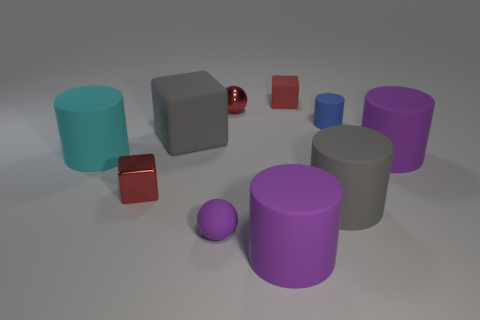Subtract all small cubes. How many cubes are left? 1 Subtract all cyan cylinders. How many cylinders are left? 4 Subtract 2 cubes. How many cubes are left? 1 Subtract all red cubes. How many purple balls are left? 1 Subtract all purple cylinders. Subtract all purple spheres. How many cylinders are left? 3 Subtract all purple rubber balls. Subtract all small purple rubber balls. How many objects are left? 8 Add 7 tiny metal blocks. How many tiny metal blocks are left? 8 Add 3 large metal things. How many large metal things exist? 3 Subtract 0 blue spheres. How many objects are left? 10 Subtract all balls. How many objects are left? 8 